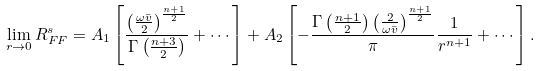<formula> <loc_0><loc_0><loc_500><loc_500>\lim _ { r \rightarrow 0 } R _ { F F } ^ { s } = A _ { 1 } \left [ \frac { \left ( \frac { \omega \bar { v } } { 2 } \right ) ^ { \frac { n + 1 } { 2 } } } { \Gamma \left ( \frac { n + 3 } { 2 } \right ) } + \cdots \right ] + A _ { 2 } \left [ - \frac { \Gamma \left ( \frac { n + 1 } { 2 } \right ) \left ( \frac { 2 } { \omega \bar { v } } \right ) ^ { \frac { n + 1 } { 2 } } } { \pi } \frac { 1 } { r ^ { n + 1 } } + \cdots \right ] .</formula> 